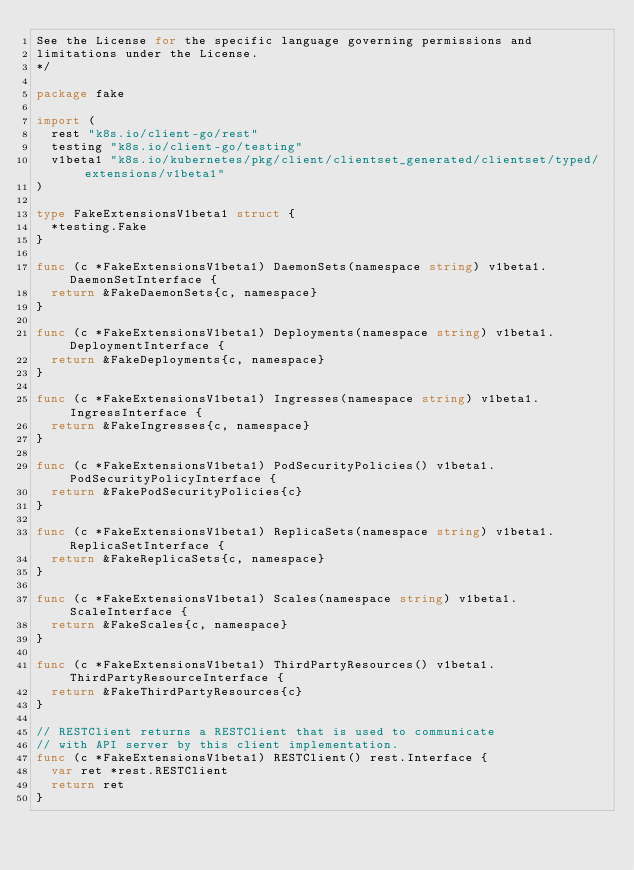Convert code to text. <code><loc_0><loc_0><loc_500><loc_500><_Go_>See the License for the specific language governing permissions and
limitations under the License.
*/

package fake

import (
	rest "k8s.io/client-go/rest"
	testing "k8s.io/client-go/testing"
	v1beta1 "k8s.io/kubernetes/pkg/client/clientset_generated/clientset/typed/extensions/v1beta1"
)

type FakeExtensionsV1beta1 struct {
	*testing.Fake
}

func (c *FakeExtensionsV1beta1) DaemonSets(namespace string) v1beta1.DaemonSetInterface {
	return &FakeDaemonSets{c, namespace}
}

func (c *FakeExtensionsV1beta1) Deployments(namespace string) v1beta1.DeploymentInterface {
	return &FakeDeployments{c, namespace}
}

func (c *FakeExtensionsV1beta1) Ingresses(namespace string) v1beta1.IngressInterface {
	return &FakeIngresses{c, namespace}
}

func (c *FakeExtensionsV1beta1) PodSecurityPolicies() v1beta1.PodSecurityPolicyInterface {
	return &FakePodSecurityPolicies{c}
}

func (c *FakeExtensionsV1beta1) ReplicaSets(namespace string) v1beta1.ReplicaSetInterface {
	return &FakeReplicaSets{c, namespace}
}

func (c *FakeExtensionsV1beta1) Scales(namespace string) v1beta1.ScaleInterface {
	return &FakeScales{c, namespace}
}

func (c *FakeExtensionsV1beta1) ThirdPartyResources() v1beta1.ThirdPartyResourceInterface {
	return &FakeThirdPartyResources{c}
}

// RESTClient returns a RESTClient that is used to communicate
// with API server by this client implementation.
func (c *FakeExtensionsV1beta1) RESTClient() rest.Interface {
	var ret *rest.RESTClient
	return ret
}
</code> 